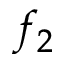Convert formula to latex. <formula><loc_0><loc_0><loc_500><loc_500>f _ { 2 }</formula> 